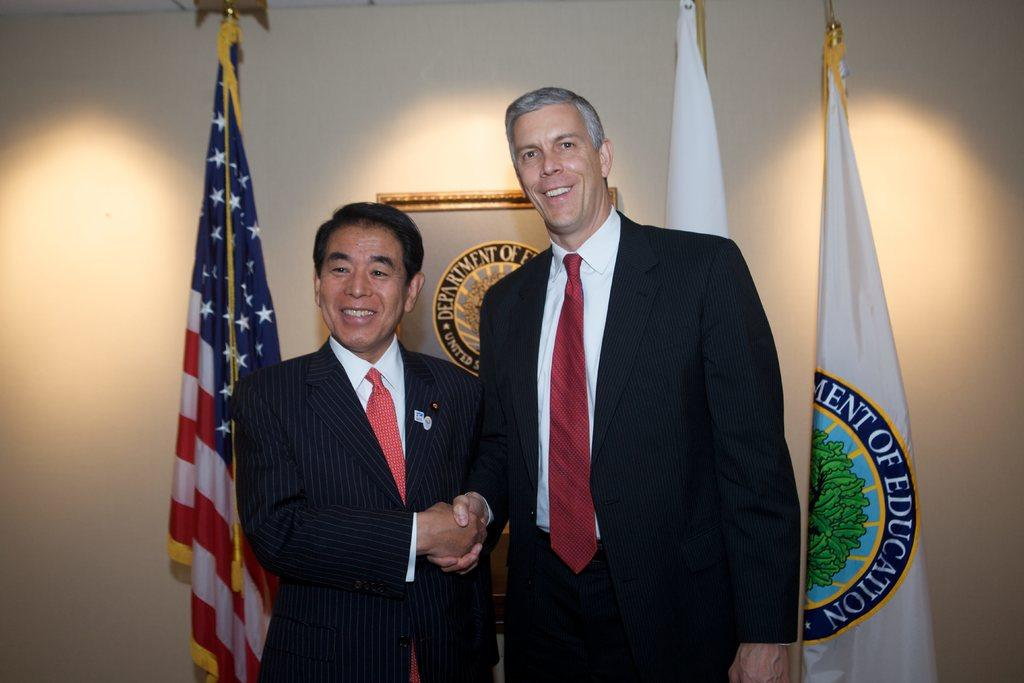How many people are in the image? There are two persons in the image. What are the two persons doing? The two persons are shaking hands. What can be seen in the background of the image? There are flags and a wall in the background of the image. Is there any symbol or design on the wall? Yes, there is a logo on the wall. What type of juice is being served in the image? There is no juice present in the image. Can you see a horse in the image? No, there is no horse in the image. 